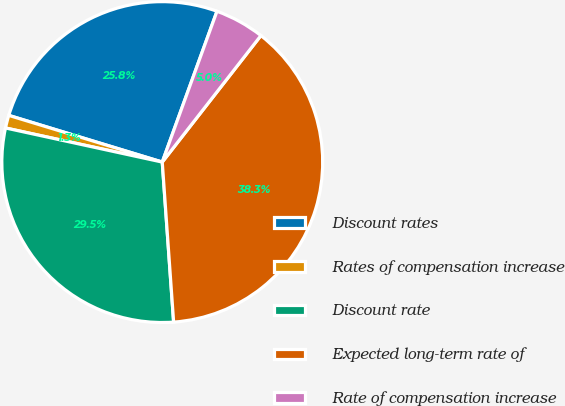Convert chart to OTSL. <chart><loc_0><loc_0><loc_500><loc_500><pie_chart><fcel>Discount rates<fcel>Rates of compensation increase<fcel>Discount rate<fcel>Expected long-term rate of<fcel>Rate of compensation increase<nl><fcel>25.84%<fcel>1.29%<fcel>29.54%<fcel>38.33%<fcel>5.0%<nl></chart> 